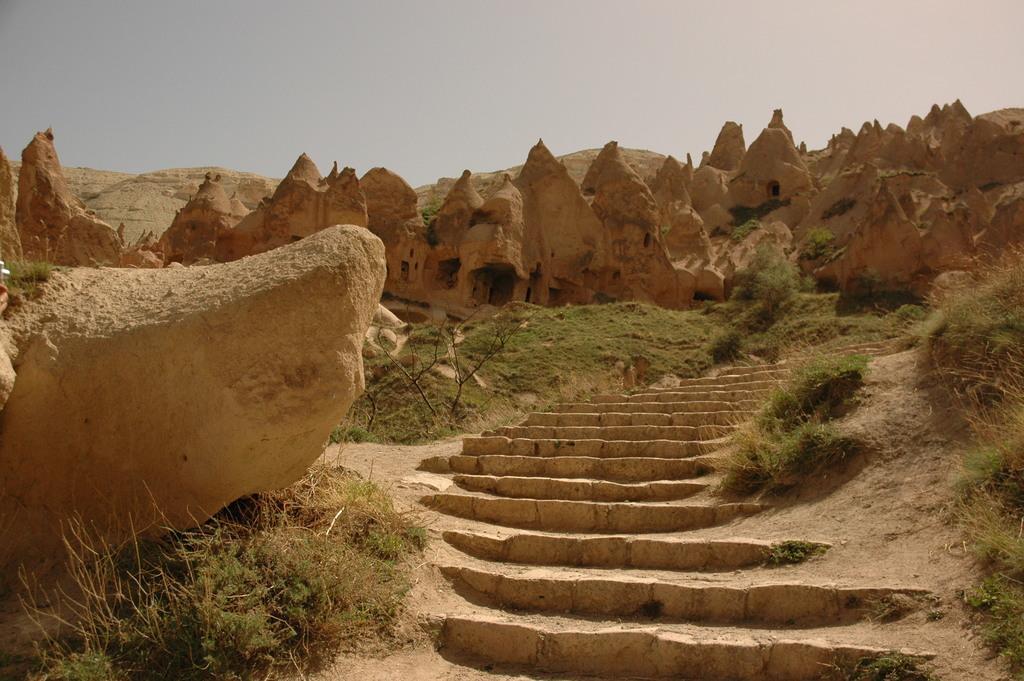Please provide a concise description of this image. In this image, there are some caves. There are steps in the middle of the image. There are some plants in the bottom left of the image. There is a sky at the top of the image. 